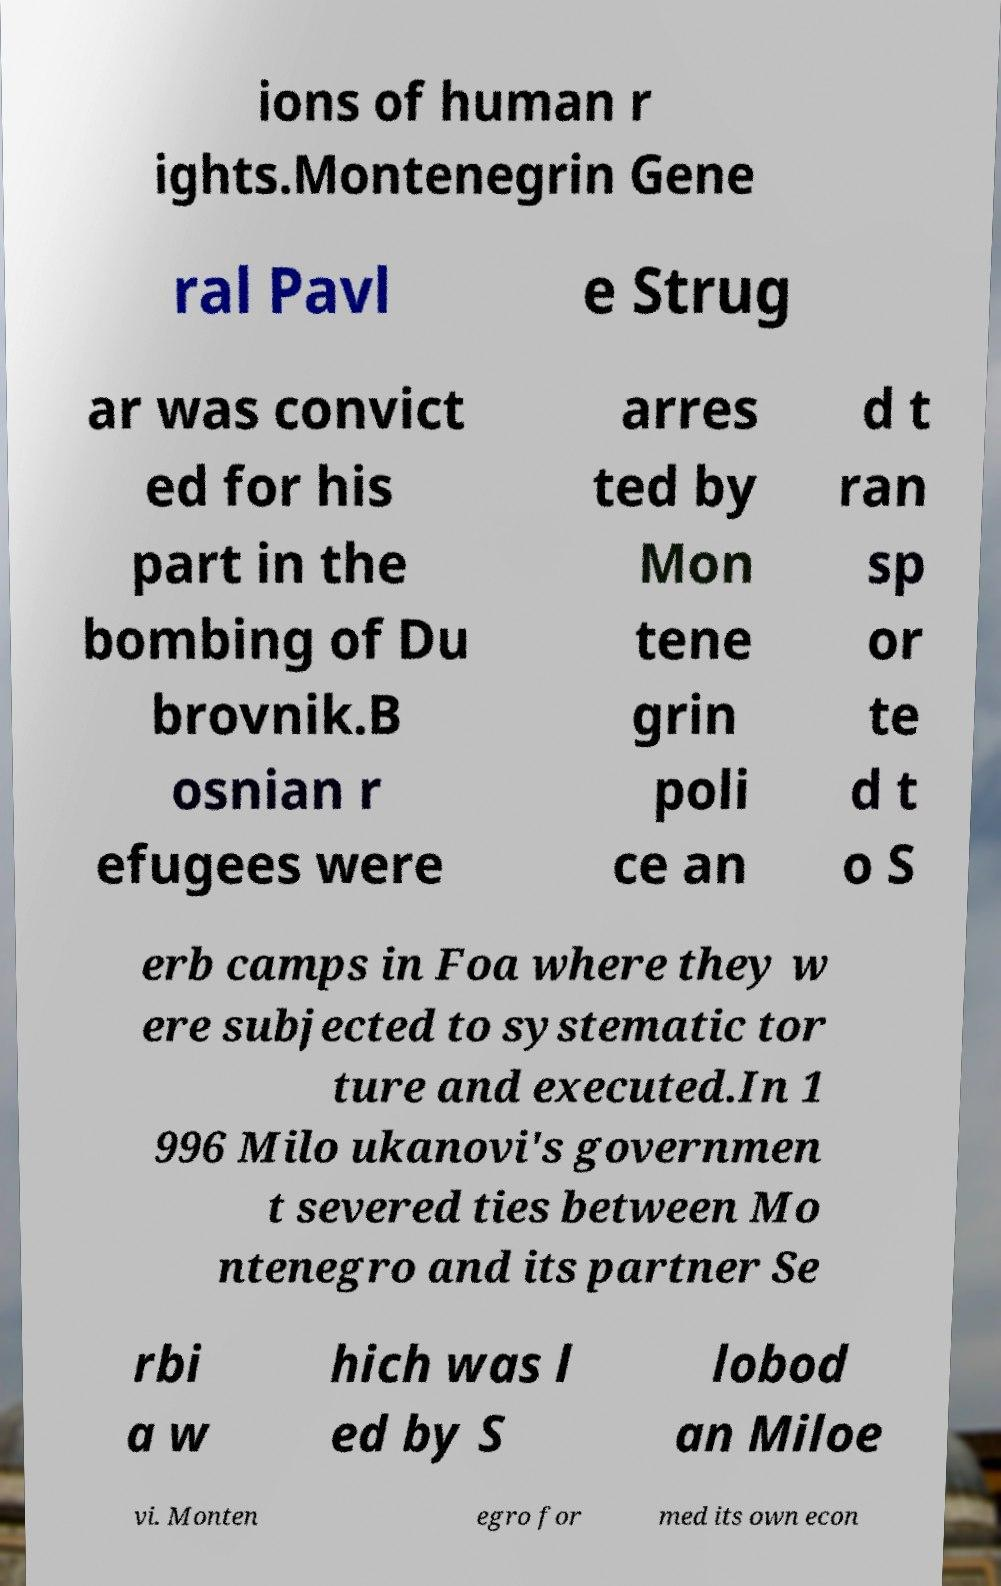Could you assist in decoding the text presented in this image and type it out clearly? ions of human r ights.Montenegrin Gene ral Pavl e Strug ar was convict ed for his part in the bombing of Du brovnik.B osnian r efugees were arres ted by Mon tene grin poli ce an d t ran sp or te d t o S erb camps in Foa where they w ere subjected to systematic tor ture and executed.In 1 996 Milo ukanovi's governmen t severed ties between Mo ntenegro and its partner Se rbi a w hich was l ed by S lobod an Miloe vi. Monten egro for med its own econ 